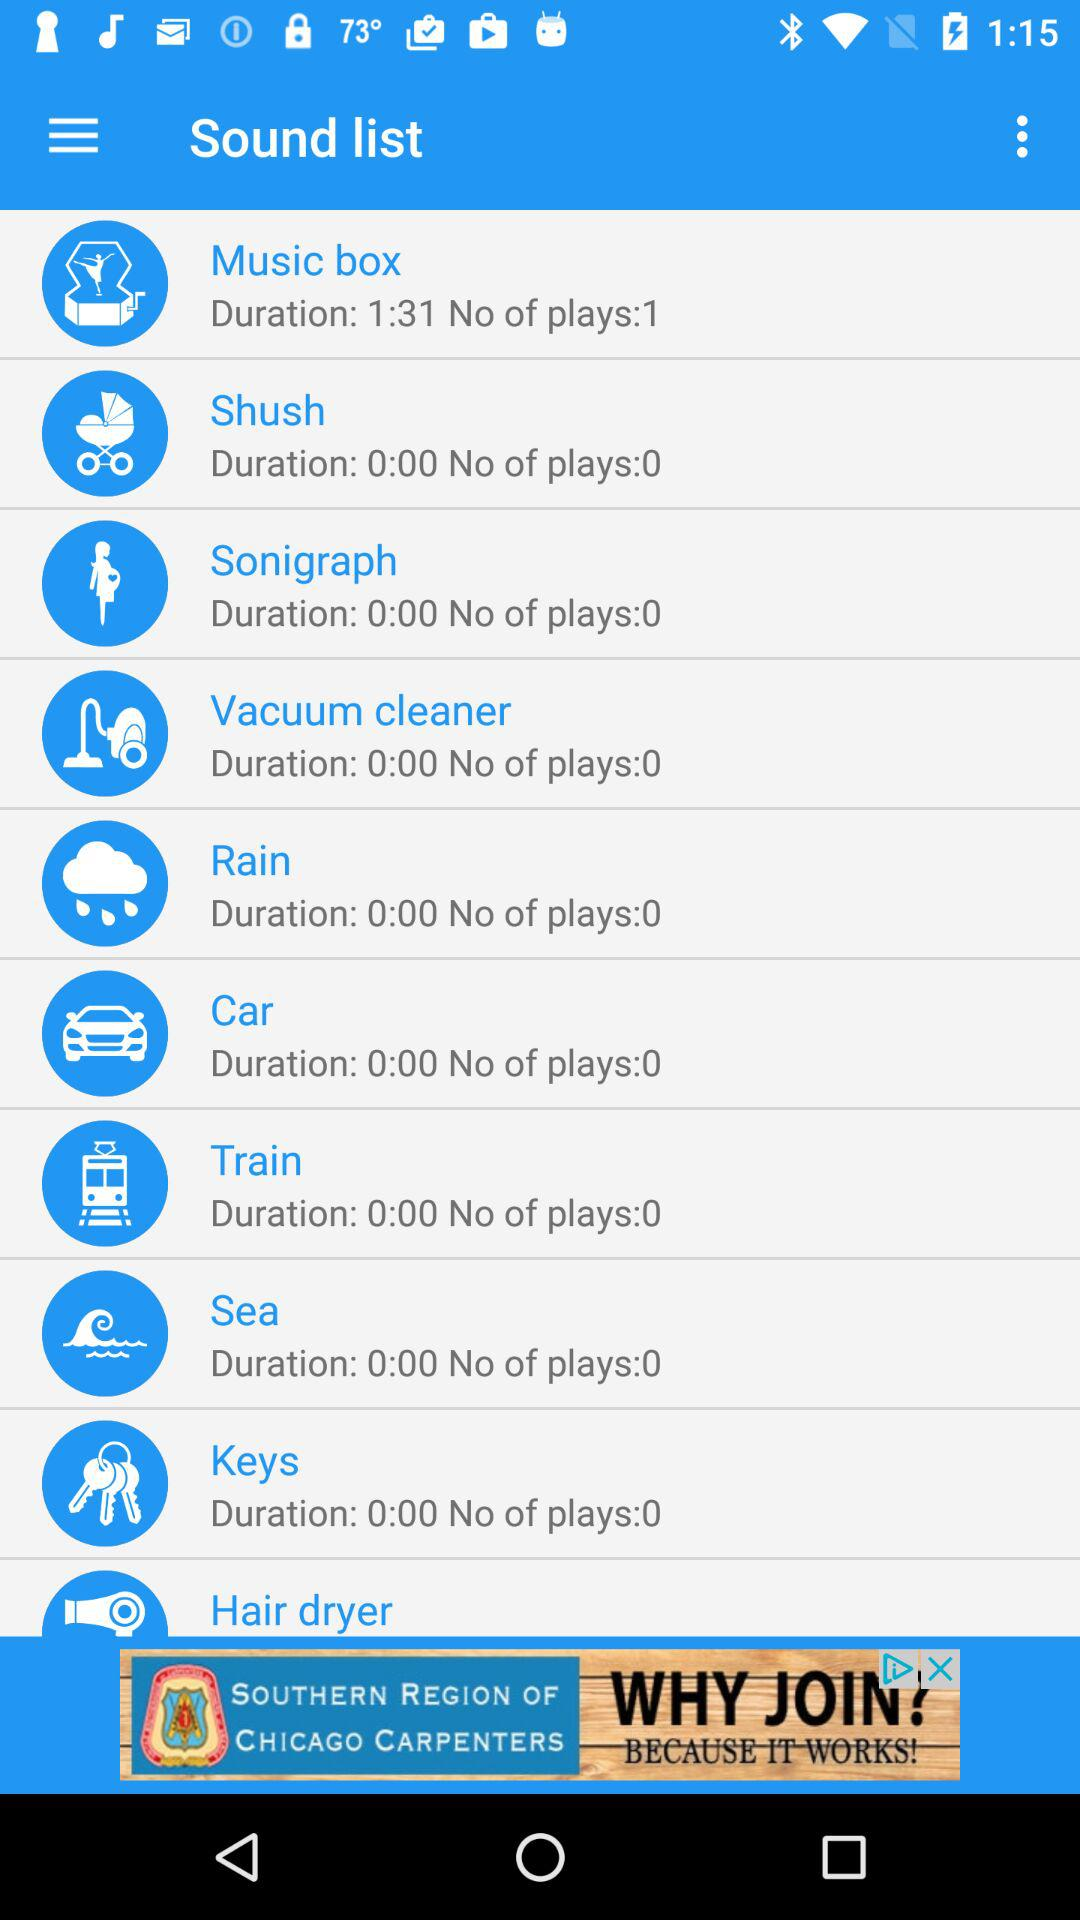What is the duration of "Music box"? The duration of "Music box" is 1 minute 31 seconds. 